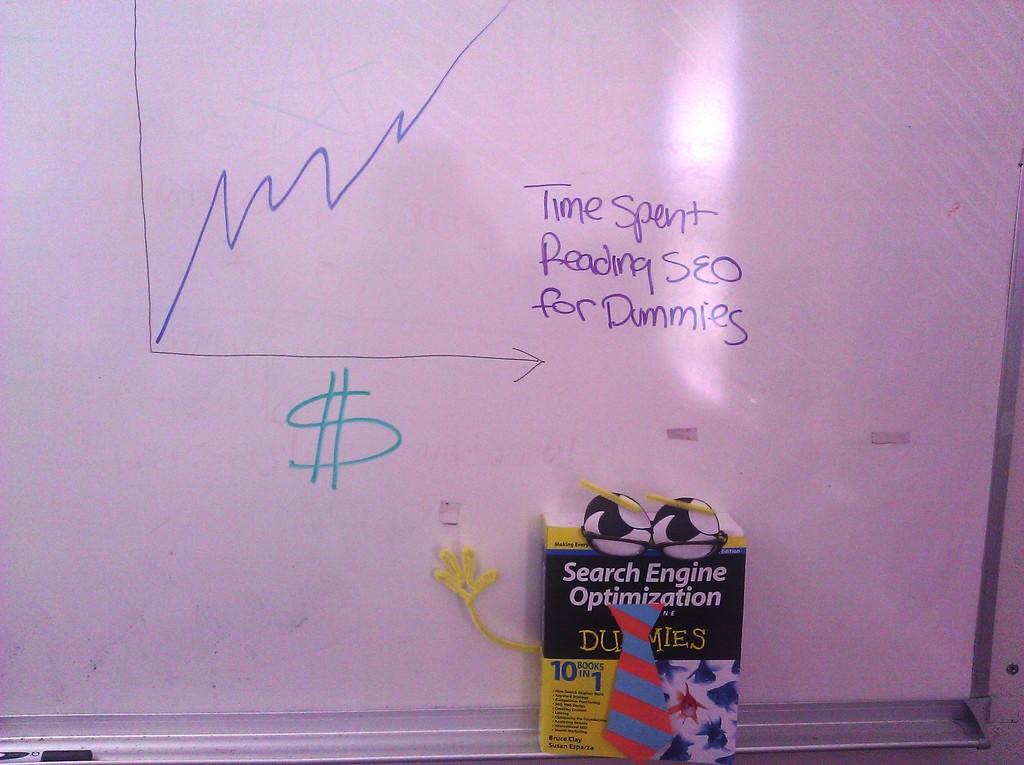What is the main object in the image? There is a whiteboard in the image. What is written or drawn on the whiteboard? Words are visible on the whiteboard. Is there anything placed in front of the whiteboard? Yes, there is a box placed in front of the whiteboard. How many men can be seen in the aftermath of the line in the image? There are no men or lines present in the image; it only features a whiteboard with words and a box in front of it. 